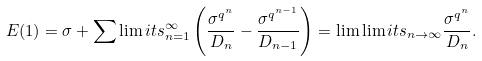<formula> <loc_0><loc_0><loc_500><loc_500>E ( 1 ) = \sigma + \sum \lim i t s _ { n = 1 } ^ { \infty } \left ( \frac { \sigma ^ { q ^ { n } } } { D _ { n } } - \frac { \sigma ^ { q ^ { n - 1 } } } { D _ { n - 1 } } \right ) = \lim \lim i t s _ { n \to \infty } \frac { \sigma ^ { q ^ { n } } } { D _ { n } } .</formula> 